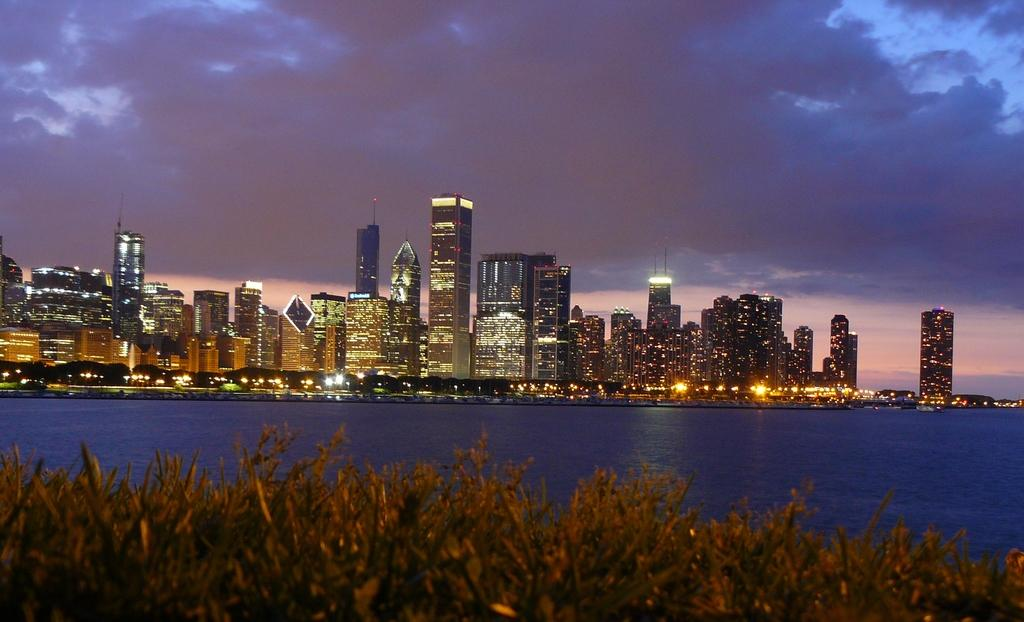What type of structures can be seen in the background of the image? There are buildings in the background of the image. What is visible in the sky in the background of the image? The sky is visible in the background of the image, and clouds are present. What is located in the center of the image? There is water in the center of the image. What type of vegetation is in the foreground of the image? There is grass in the foreground of the image. How many beads are scattered on the grass in the image? There are no beads present in the image; it features buildings, water, grass, and clouds. What type of air is visible in the image? There is no specific type of air visible in the image; it simply shows the sky, clouds, and other elements. 